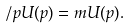<formula> <loc_0><loc_0><loc_500><loc_500>\slash { p } U ( p ) = m U ( p ) .</formula> 